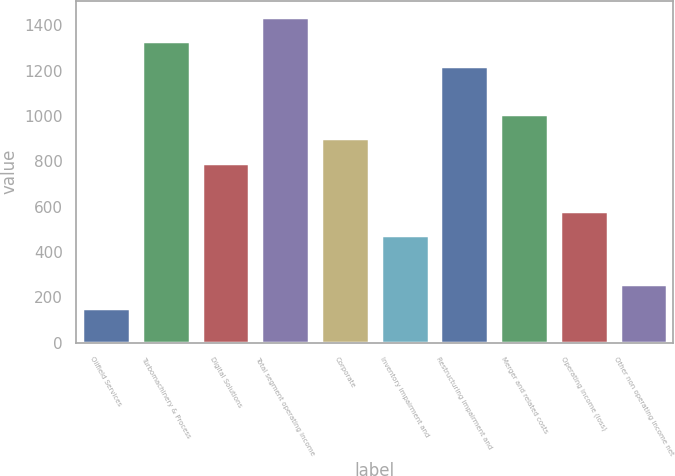Convert chart. <chart><loc_0><loc_0><loc_500><loc_500><bar_chart><fcel>Oilfield Services<fcel>Turbomachinery & Process<fcel>Digital Solutions<fcel>Total segment operating income<fcel>Corporate<fcel>Inventory impairment and<fcel>Restructuring impairment and<fcel>Merger and related costs<fcel>Operating income (loss)<fcel>Other non operating income net<nl><fcel>152<fcel>1329<fcel>794<fcel>1436<fcel>901<fcel>473<fcel>1222<fcel>1008<fcel>580<fcel>259<nl></chart> 